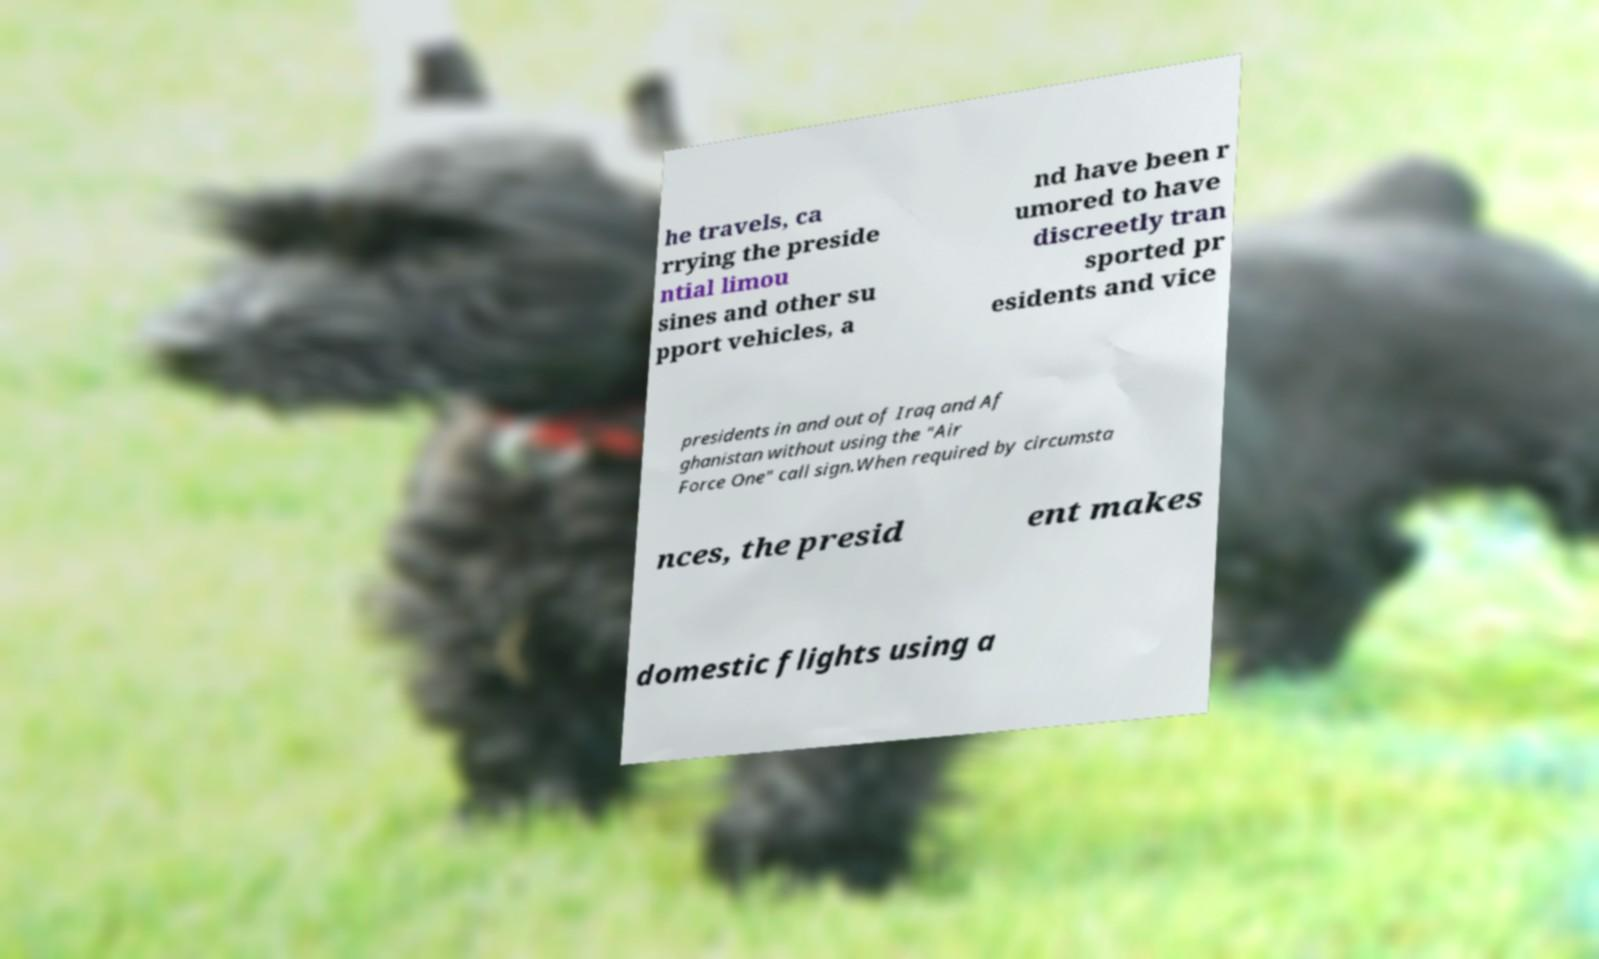Can you accurately transcribe the text from the provided image for me? he travels, ca rrying the preside ntial limou sines and other su pport vehicles, a nd have been r umored to have discreetly tran sported pr esidents and vice presidents in and out of Iraq and Af ghanistan without using the "Air Force One" call sign.When required by circumsta nces, the presid ent makes domestic flights using a 